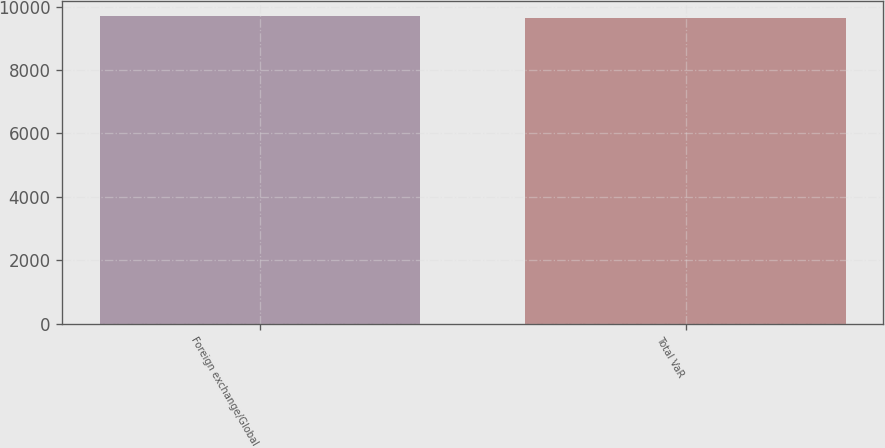Convert chart to OTSL. <chart><loc_0><loc_0><loc_500><loc_500><bar_chart><fcel>Foreign exchange/Global<fcel>Total VaR<nl><fcel>9704<fcel>9648<nl></chart> 